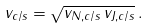Convert formula to latex. <formula><loc_0><loc_0><loc_500><loc_500>v _ { c / s } = \sqrt { v _ { N , c / s } \, v _ { J , c / s } } \, .</formula> 